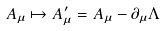Convert formula to latex. <formula><loc_0><loc_0><loc_500><loc_500>A _ { \mu } \mapsto A ^ { \prime } _ { \mu } = A _ { \mu } - \partial _ { \mu } \Lambda</formula> 